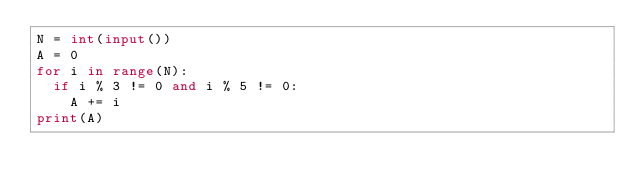Convert code to text. <code><loc_0><loc_0><loc_500><loc_500><_Python_>N = int(input())
A = 0
for i in range(N):
  if i % 3 != 0 and i % 5 != 0:
    A += i
print(A)</code> 